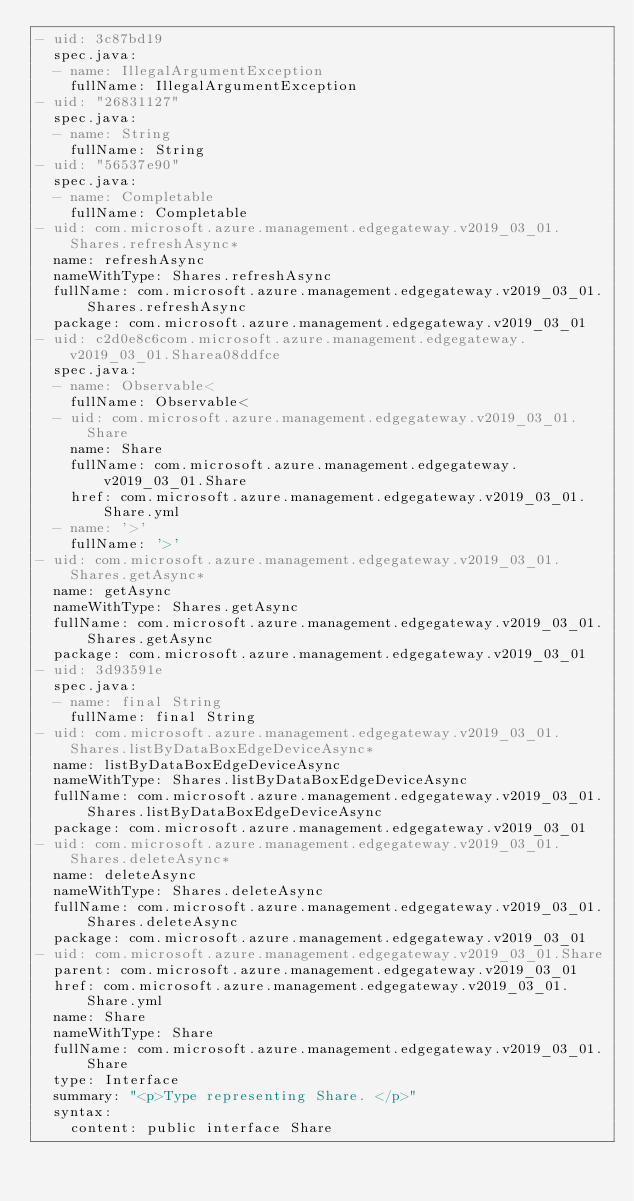<code> <loc_0><loc_0><loc_500><loc_500><_YAML_>- uid: 3c87bd19
  spec.java:
  - name: IllegalArgumentException
    fullName: IllegalArgumentException
- uid: "26831127"
  spec.java:
  - name: String
    fullName: String
- uid: "56537e90"
  spec.java:
  - name: Completable
    fullName: Completable
- uid: com.microsoft.azure.management.edgegateway.v2019_03_01.Shares.refreshAsync*
  name: refreshAsync
  nameWithType: Shares.refreshAsync
  fullName: com.microsoft.azure.management.edgegateway.v2019_03_01.Shares.refreshAsync
  package: com.microsoft.azure.management.edgegateway.v2019_03_01
- uid: c2d0e8c6com.microsoft.azure.management.edgegateway.v2019_03_01.Sharea08ddfce
  spec.java:
  - name: Observable<
    fullName: Observable<
  - uid: com.microsoft.azure.management.edgegateway.v2019_03_01.Share
    name: Share
    fullName: com.microsoft.azure.management.edgegateway.v2019_03_01.Share
    href: com.microsoft.azure.management.edgegateway.v2019_03_01.Share.yml
  - name: '>'
    fullName: '>'
- uid: com.microsoft.azure.management.edgegateway.v2019_03_01.Shares.getAsync*
  name: getAsync
  nameWithType: Shares.getAsync
  fullName: com.microsoft.azure.management.edgegateway.v2019_03_01.Shares.getAsync
  package: com.microsoft.azure.management.edgegateway.v2019_03_01
- uid: 3d93591e
  spec.java:
  - name: final String
    fullName: final String
- uid: com.microsoft.azure.management.edgegateway.v2019_03_01.Shares.listByDataBoxEdgeDeviceAsync*
  name: listByDataBoxEdgeDeviceAsync
  nameWithType: Shares.listByDataBoxEdgeDeviceAsync
  fullName: com.microsoft.azure.management.edgegateway.v2019_03_01.Shares.listByDataBoxEdgeDeviceAsync
  package: com.microsoft.azure.management.edgegateway.v2019_03_01
- uid: com.microsoft.azure.management.edgegateway.v2019_03_01.Shares.deleteAsync*
  name: deleteAsync
  nameWithType: Shares.deleteAsync
  fullName: com.microsoft.azure.management.edgegateway.v2019_03_01.Shares.deleteAsync
  package: com.microsoft.azure.management.edgegateway.v2019_03_01
- uid: com.microsoft.azure.management.edgegateway.v2019_03_01.Share
  parent: com.microsoft.azure.management.edgegateway.v2019_03_01
  href: com.microsoft.azure.management.edgegateway.v2019_03_01.Share.yml
  name: Share
  nameWithType: Share
  fullName: com.microsoft.azure.management.edgegateway.v2019_03_01.Share
  type: Interface
  summary: "<p>Type representing Share. </p>"
  syntax:
    content: public interface Share
</code> 